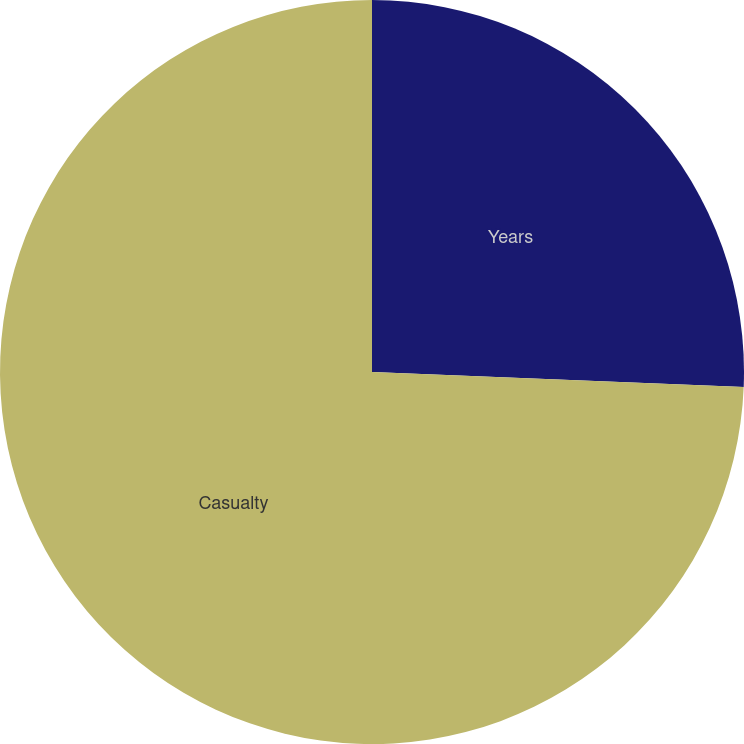Convert chart to OTSL. <chart><loc_0><loc_0><loc_500><loc_500><pie_chart><fcel>Years<fcel>Casualty<nl><fcel>25.64%<fcel>74.36%<nl></chart> 